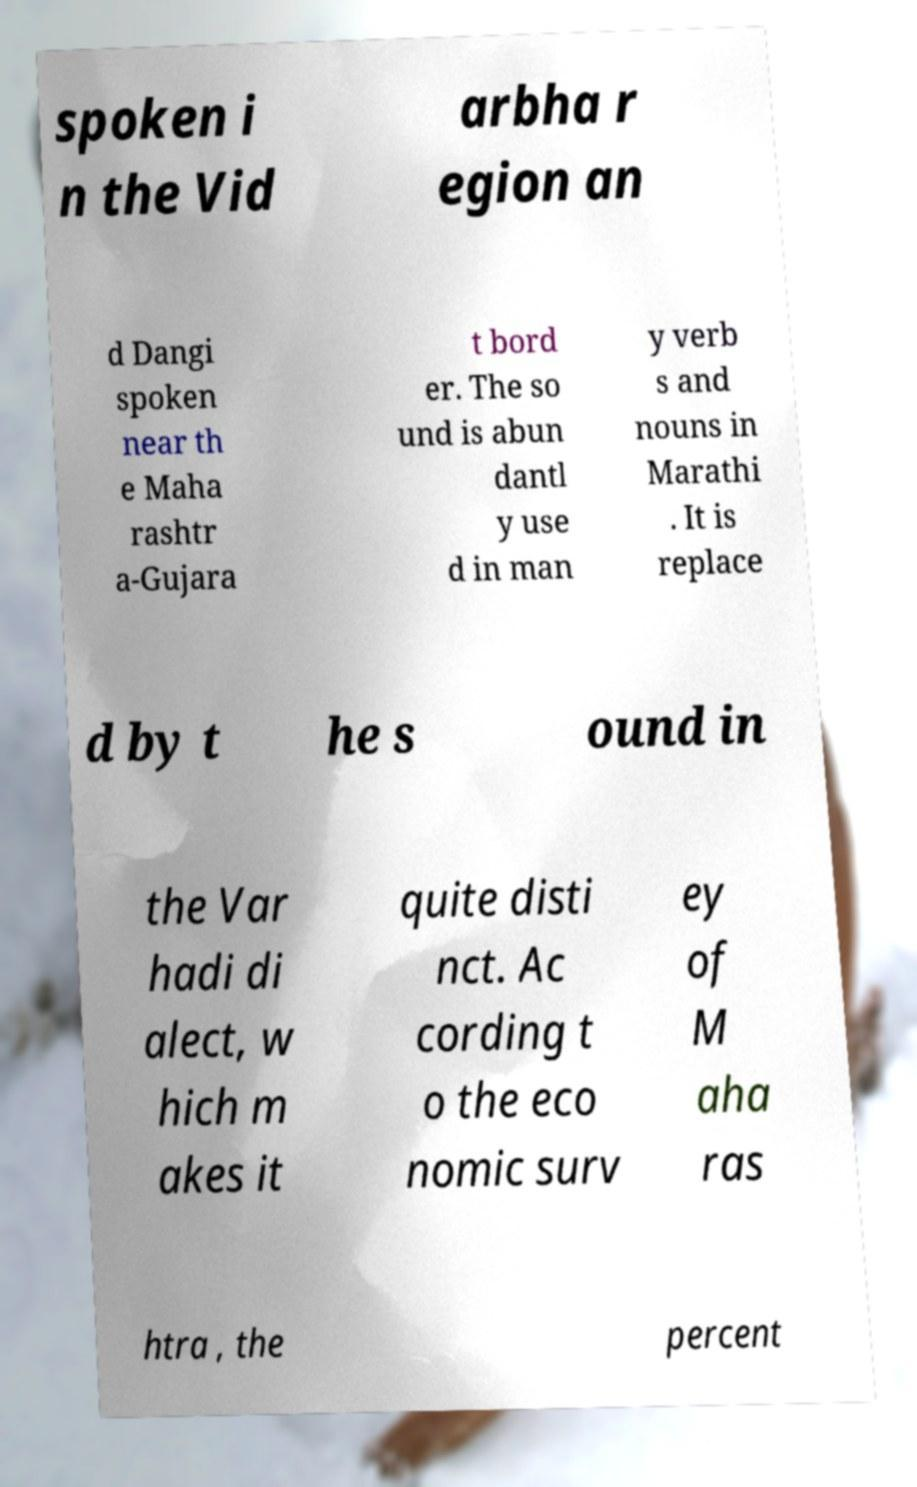For documentation purposes, I need the text within this image transcribed. Could you provide that? spoken i n the Vid arbha r egion an d Dangi spoken near th e Maha rashtr a-Gujara t bord er. The so und is abun dantl y use d in man y verb s and nouns in Marathi . It is replace d by t he s ound in the Var hadi di alect, w hich m akes it quite disti nct. Ac cording t o the eco nomic surv ey of M aha ras htra , the percent 